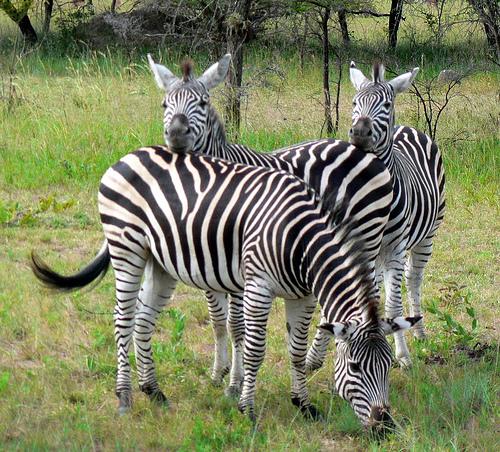How many zebra are in this photo?
Give a very brief answer. 3. How many legs are there?
Keep it brief. 12. Is the grass green?
Answer briefly. Yes. 